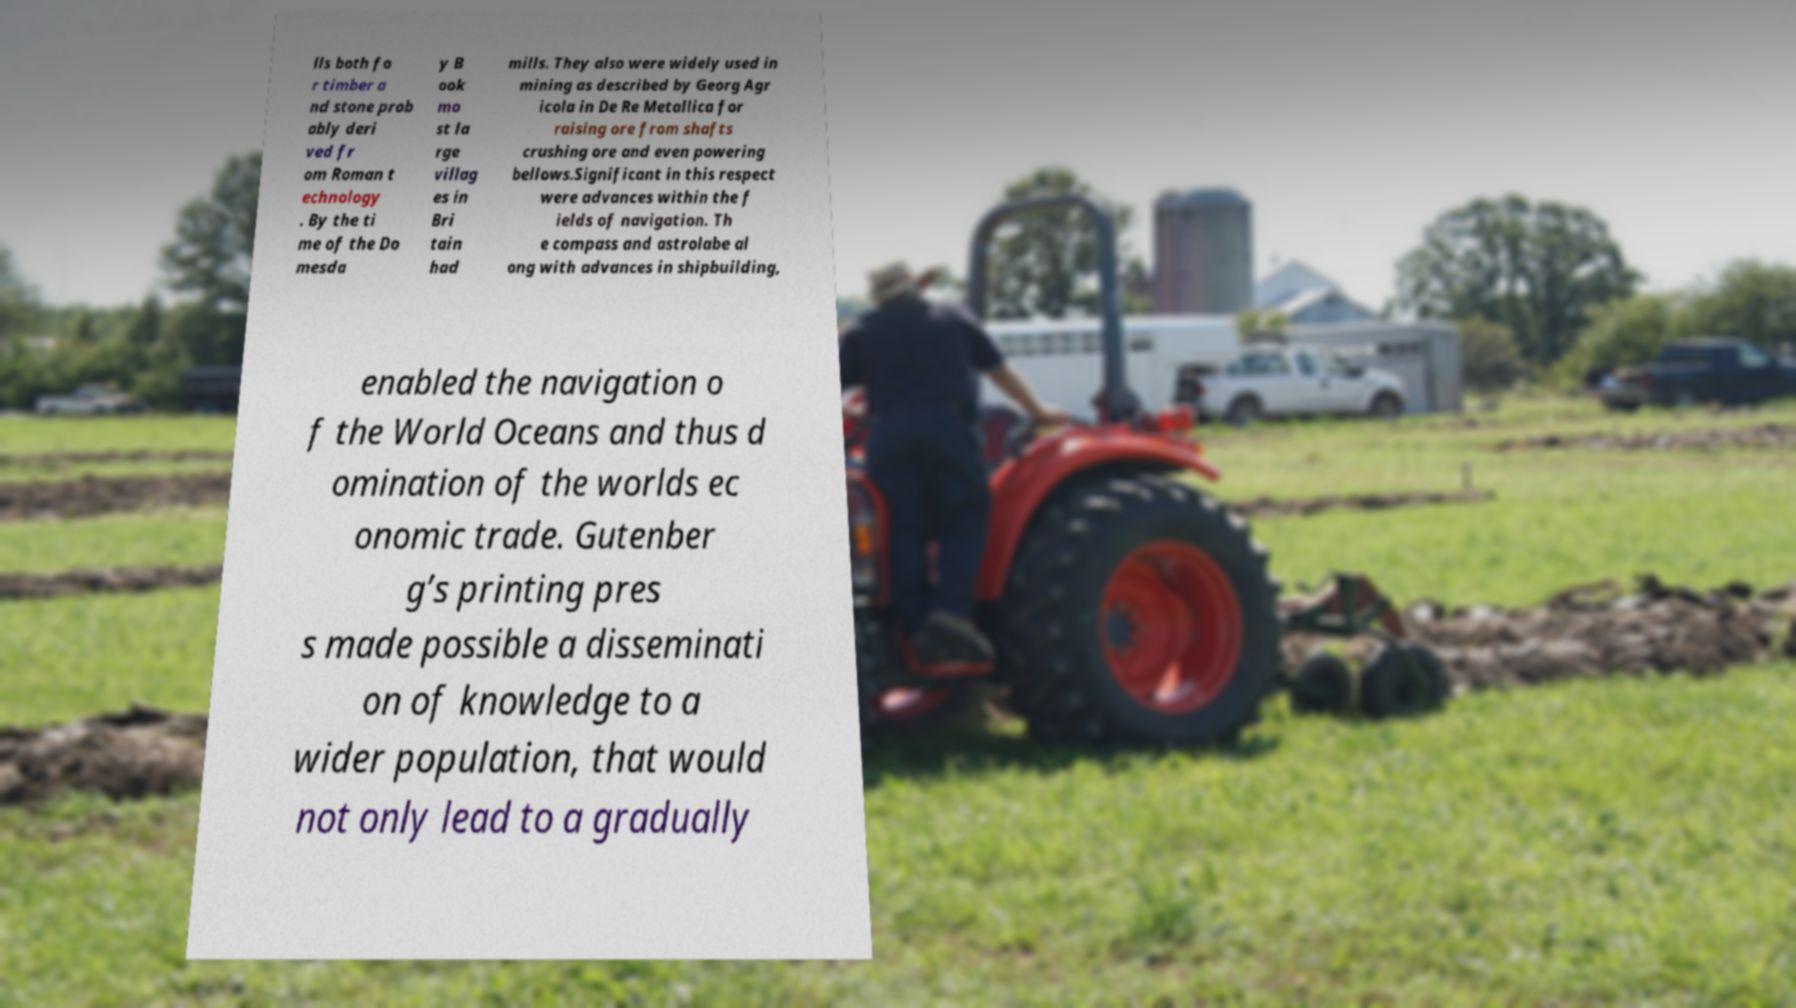Can you accurately transcribe the text from the provided image for me? lls both fo r timber a nd stone prob ably deri ved fr om Roman t echnology . By the ti me of the Do mesda y B ook mo st la rge villag es in Bri tain had mills. They also were widely used in mining as described by Georg Agr icola in De Re Metallica for raising ore from shafts crushing ore and even powering bellows.Significant in this respect were advances within the f ields of navigation. Th e compass and astrolabe al ong with advances in shipbuilding, enabled the navigation o f the World Oceans and thus d omination of the worlds ec onomic trade. Gutenber g’s printing pres s made possible a disseminati on of knowledge to a wider population, that would not only lead to a gradually 